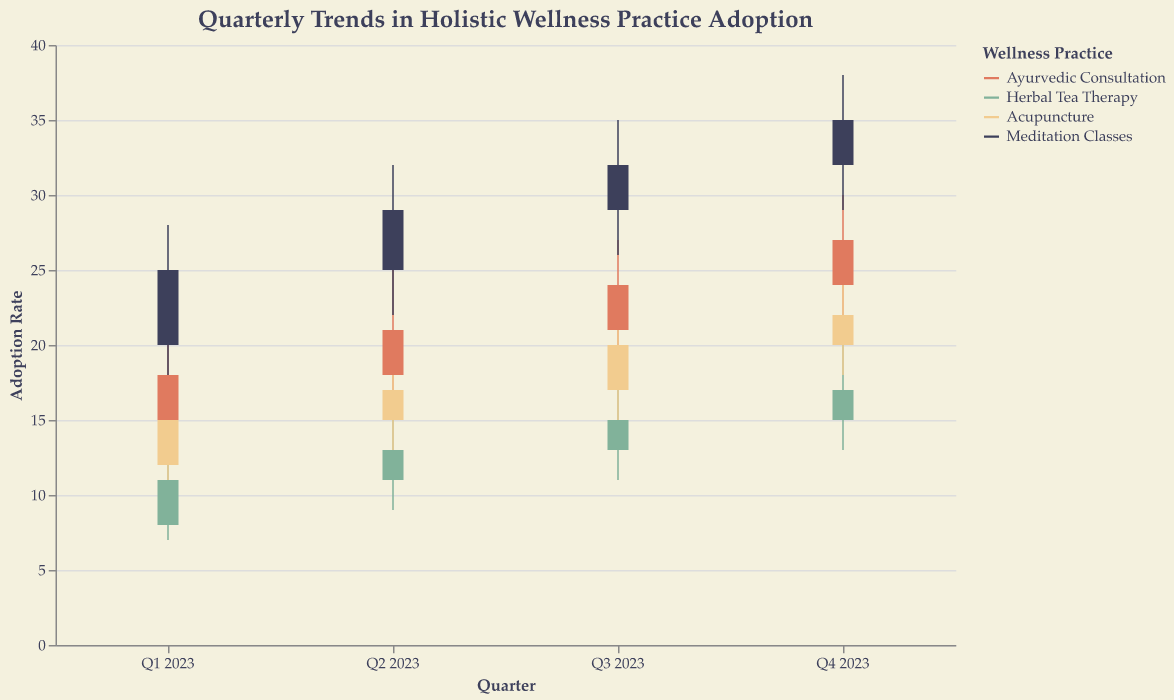What is the highest adoption rate for Meditation Classes in any quarter? The highest adoption rate for Meditation Classes is found in Q4 2023, with a peak (High) value of 38.
Answer: 38 Which wellness practice had the lowest adoption rate in Q2 2023? The lowest adoption rates can be found by checking the Low values for each practice in Q2 2023. Ayurvedic Consultation (16), Herbal Tea Therapy (9), Acupuncture (13), Meditation Classes (22). The lowest rate is for Herbal Tea Therapy with a Low value of 9.
Answer: Herbal Tea Therapy Did the adoption rate for Acupuncture ever surpass the adoption rate for Ayurvedic Consultation in any quarter? For each quarter, compare the High values for both practices. There is no quarter where the High value of Acupuncture surpasses the High value of Ayurvedic Consultation (Acupuncture Vs Ayurvedic: Q1 17 vs 22, Q2 20 vs 25, Q3 23 vs 27, Q4 25 vs 30).
Answer: No Which practice had the greatest increase in adoption between Q1 2023 and Q4 2023? Compare the difference between Open and Close values for each practice from Q1 to Q4: Ayurvedic (+9), Herbal Tea (+9), Acupuncture (+10), Meditation Classes (+15). Meditation Classes had the greatest increase from an Open value of 20 in Q1 to a Close value of 35 in Q4.
Answer: Meditation Classes What was the highest increase in any practice’s adoption between two contiguous quarters? Evaluate the increase for each practice between contiguous quarters by checking the High values. The largest increase is in Meditation Classes from Q2 (High 32) to Q3 (High 35), an increase of 3.
Answer: Meditation Classes between Q2 and Q3 What trend can be observed in the adoption rate for Herbal Tea Therapy across the four quarters of 2023? Herbal Tea Therapy shows a gradual increase in the Close values across the quarters: 11 in Q1, 13 in Q2, 15 in Q3, and 17 in Q4, with steady rises in Open values as well.
Answer: Gradual Increase Which practice showed the most stable adoption rates with the smallest range between its High and Low values in any single quarter? Calculate the range (High-Low) for each practice in each quarter to find the smallest difference. For Q1: Ayurvedic (10), Herbal Tea (7), Acupuncture (7), Meditation (10). For Q2: Ayurvedic (9), Herbal Tea (7), Acupuncture (7), Meditation (10). For Q3: Ayurvedic (8), Herbal Tea (7), Acupuncture (8), Meditation (9). For Q4: Ayurvedic (8), Herbal Tea (7), Acupuncture (7), Meditation (9). The smallest consistent range across all quarters is observed in Herbal Tea Therapy.
Answer: Herbal Tea Therapy Considering the overall trends, which practice seems to be gaining the most popularity by the end of the year? All practices have increasing adoption rates when comparing Open values in Q1 to Close values in Q4. However, Meditation Classes show the highest closing value and the greatest overall increase (from a Close of 25 in Q1 to 35 in Q4).
Answer: Meditation Classes 